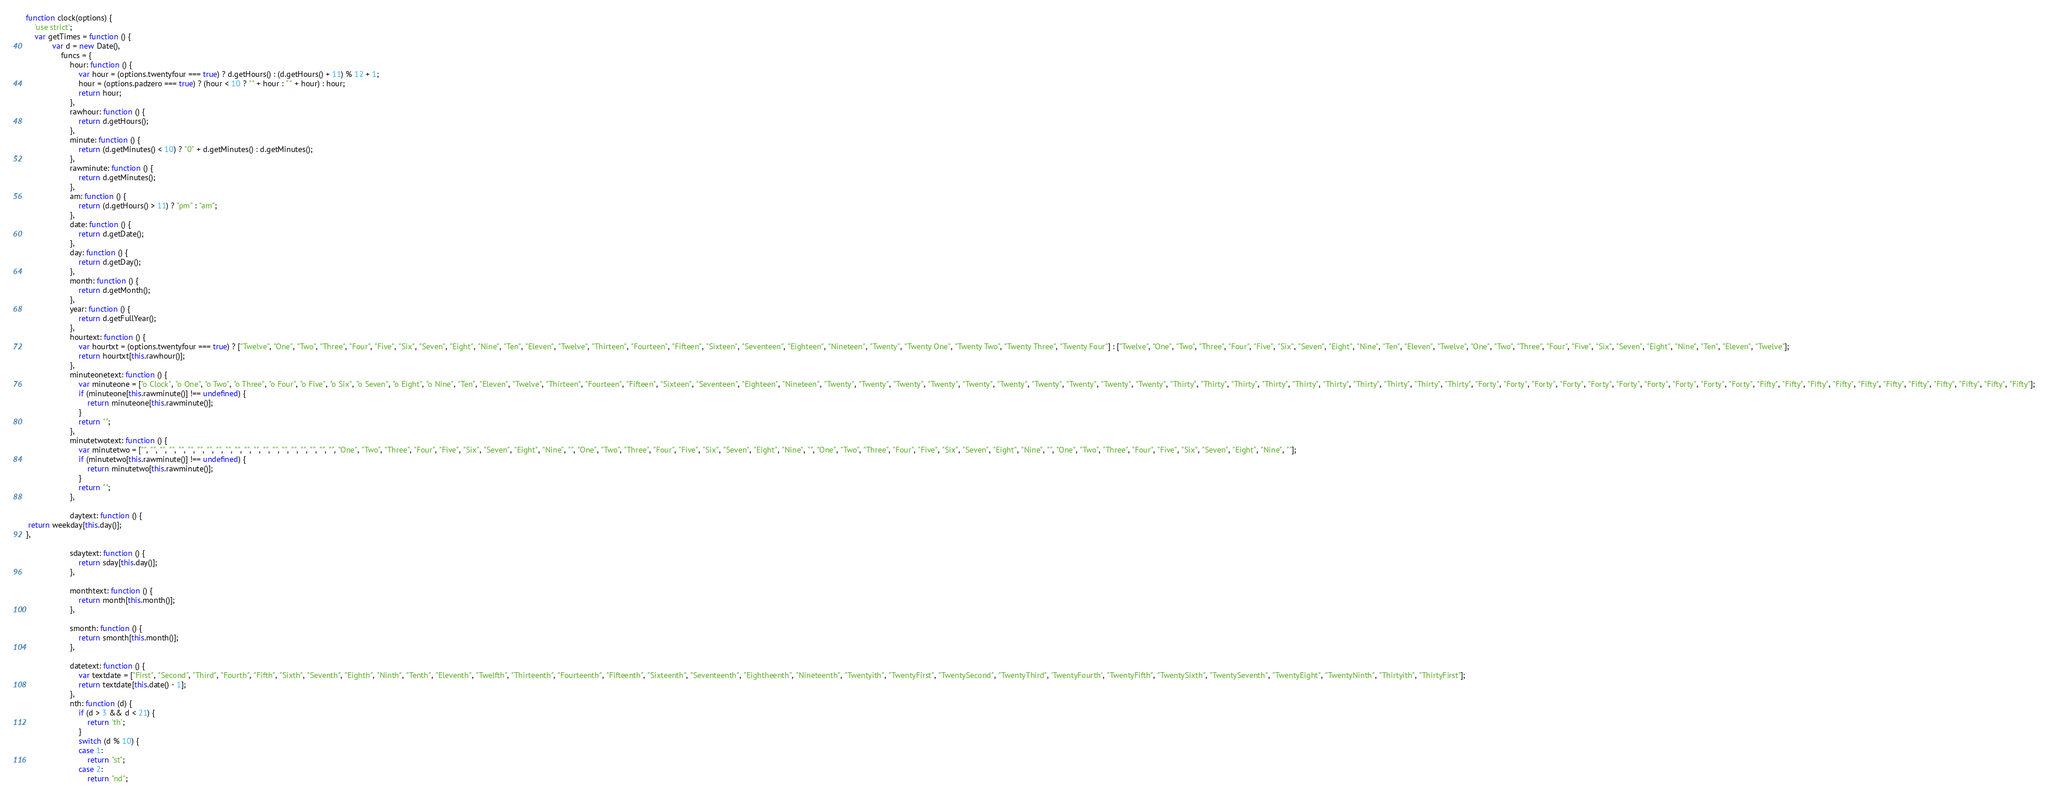<code> <loc_0><loc_0><loc_500><loc_500><_JavaScript_>function clock(options) {
    'use strict';
    var getTimes = function () {
            var d = new Date(),
                funcs = {
                    hour: function () {
                        var hour = (options.twentyfour === true) ? d.getHours() : (d.getHours() + 11) % 12 + 1;
                        hour = (options.padzero === true) ? (hour < 10 ? "" + hour : " " + hour) : hour;
                        return hour;
                    },
                    rawhour: function () {
                        return d.getHours();
                    },
                    minute: function () {
                        return (d.getMinutes() < 10) ? "0" + d.getMinutes() : d.getMinutes();
                    },
                    rawminute: function () {
                        return d.getMinutes();
                    },
                    am: function () {
                        return (d.getHours() > 11) ? "pm" : "am";
                    },
                    date: function () {
                        return d.getDate();
                    },
                    day: function () {
                        return d.getDay();
                    },
                    month: function () {
                        return d.getMonth();
                    },
                    year: function () {
                        return d.getFullYear();
                    },
                    hourtext: function () {
                        var hourtxt = (options.twentyfour === true) ? ["Twelve", "One", "Two", "Three", "Four", "Five", "Six", "Seven", "Eight", "Nine", "Ten", "Eleven", "Twelve", "Thirteen", "Fourteen", "Fifteen", "Sixteen", "Seventeen", "Eighteen", "Nineteen", "Twenty", "Twenty One", "Twenty Two", "Twenty Three", "Twenty Four"] : ["Twelve", "One", "Two", "Three", "Four", "Five", "Six", "Seven", "Eight", "Nine", "Ten", "Eleven", "Twelve", "One", "Two", "Three", "Four", "Five", "Six", "Seven", "Eight", "Nine", "Ten", "Eleven", "Twelve"];
                        return hourtxt[this.rawhour()];
                    },
                    minuteonetext: function () {
                        var minuteone = ["o Clock", "o One", "o Two", "o Three", "o Four", "o Five", "o Six", "o Seven", "o Eight", "o Nine", "Ten", "Eleven", "Twelve", "Thirteen", "Fourteen", "Fifteen", "Sixteen", "Seventeen", "Eighteen", "Nineteen", "Twenty", "Twenty", "Twenty", "Twenty", "Twenty", "Twenty", "Twenty", "Twenty", "Twenty", "Twenty", "Thirty", "Thirty", "Thirty", "Thirty", "Thirty", "Thirty", "Thirty", "Thirty", "Thirty", "Thirty", "Forty", "Forty", "Forty", "Forty", "Forty", "Forty", "Forty", "Forty", "Forty", "Forty", "Fifty", "Fifty", "Fifty", "Fifty", "Fifty", "Fifty", "Fifty", "Fifty", "Fifty", "Fifty", "Fifty"];
                        if (minuteone[this.rawminute()] !== undefined) {
                            return minuteone[this.rawminute()];
                        }
                        return "";
                    },
                    minutetwotext: function () {
                        var minutetwo = ["", "", "", "", "", "", "", "", "", "", "", "", "", "", "", "", "", "", "", "", "", "One", "Two", "Three", "Four", "Five", "Six", "Seven", "Eight", "Nine", "", "One", "Two", "Three", "Four", "Five", "Six", "Seven", "Eight", "Nine", "", "One", "Two", "Three", "Four", "Five", "Six", "Seven", "Eight", "Nine", "", "One", "Two", "Three", "Four", "Five", "Six", "Seven", "Eight", "Nine", ""];
                        if (minutetwo[this.rawminute()] !== undefined) {
                            return minutetwo[this.rawminute()];
                        }
                        return "";
                    },

                    daytext: function () {
 return weekday[this.day()];
},
                            
                    sdaytext: function () {
                        return sday[this.day()];
                    },

                    monthtext: function () {
                        return month[this.month()];
                    },
                    
                    smonth: function () {
                        return smonth[this.month()];
                    },

                    datetext: function () {
                        var textdate = ["First", "Second", "Third", "Fourth", "Fifth", "Sixth", "Seventh", "Eighth", "Ninth", "Tenth", "Eleventh", "Twelfth", "Thirteenth", "Fourteenth", "Fifteenth", "Sixteenth", "Seventeenth", "Eightheenth", "Nineteenth", "Twentyith", "TwentyFirst", "TwentySecond", "TwentyThird", 'TwentyFourth', "TwentyFifth", "TwentySixth", "TwentySeventh", "TwentyEight", "TwentyNinth", "Thirtyith", "ThirtyFirst"];
                        return textdate[this.date() - 1];
                    },
                    nth: function (d) {
                        if (d > 3 && d < 21) {
                            return 'th';
                        }
                        switch (d % 10) {
                        case 1:
                            return "st";
                        case 2:
                            return "nd";</code> 